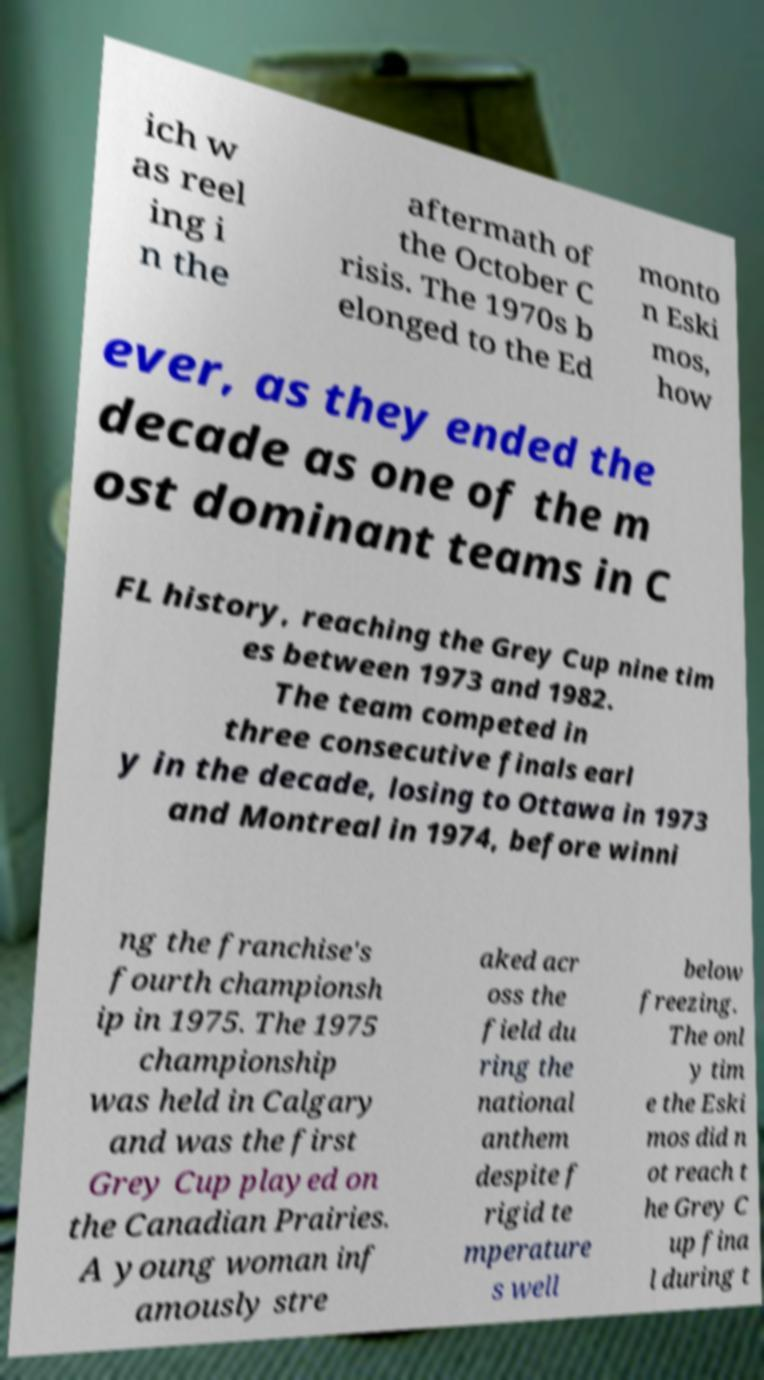Could you extract and type out the text from this image? ich w as reel ing i n the aftermath of the October C risis. The 1970s b elonged to the Ed monto n Eski mos, how ever, as they ended the decade as one of the m ost dominant teams in C FL history, reaching the Grey Cup nine tim es between 1973 and 1982. The team competed in three consecutive finals earl y in the decade, losing to Ottawa in 1973 and Montreal in 1974, before winni ng the franchise's fourth championsh ip in 1975. The 1975 championship was held in Calgary and was the first Grey Cup played on the Canadian Prairies. A young woman inf amously stre aked acr oss the field du ring the national anthem despite f rigid te mperature s well below freezing. The onl y tim e the Eski mos did n ot reach t he Grey C up fina l during t 